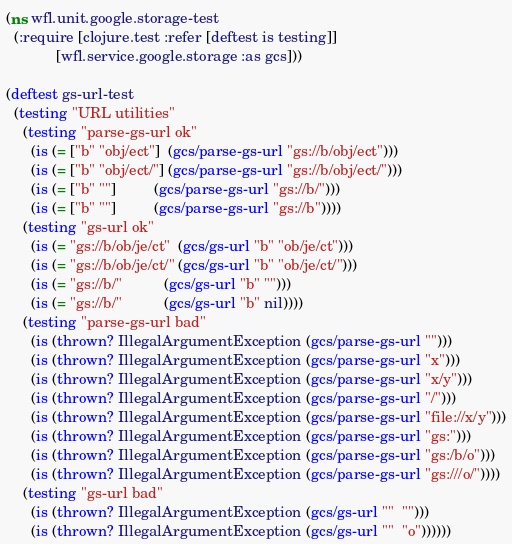<code> <loc_0><loc_0><loc_500><loc_500><_Clojure_>(ns wfl.unit.google.storage-test
  (:require [clojure.test :refer [deftest is testing]]
            [wfl.service.google.storage :as gcs]))

(deftest gs-url-test
  (testing "URL utilities"
    (testing "parse-gs-url ok"
      (is (= ["b" "obj/ect"]  (gcs/parse-gs-url "gs://b/obj/ect")))
      (is (= ["b" "obj/ect/"] (gcs/parse-gs-url "gs://b/obj/ect/")))
      (is (= ["b" ""]         (gcs/parse-gs-url "gs://b/")))
      (is (= ["b" ""]         (gcs/parse-gs-url "gs://b"))))
    (testing "gs-url ok"
      (is (= "gs://b/ob/je/ct"  (gcs/gs-url "b" "ob/je/ct")))
      (is (= "gs://b/ob/je/ct/" (gcs/gs-url "b" "ob/je/ct/")))
      (is (= "gs://b/"          (gcs/gs-url "b" "")))
      (is (= "gs://b/"          (gcs/gs-url "b" nil))))
    (testing "parse-gs-url bad"
      (is (thrown? IllegalArgumentException (gcs/parse-gs-url "")))
      (is (thrown? IllegalArgumentException (gcs/parse-gs-url "x")))
      (is (thrown? IllegalArgumentException (gcs/parse-gs-url "x/y")))
      (is (thrown? IllegalArgumentException (gcs/parse-gs-url "/")))
      (is (thrown? IllegalArgumentException (gcs/parse-gs-url "file://x/y")))
      (is (thrown? IllegalArgumentException (gcs/parse-gs-url "gs:")))
      (is (thrown? IllegalArgumentException (gcs/parse-gs-url "gs:/b/o")))
      (is (thrown? IllegalArgumentException (gcs/parse-gs-url "gs:///o/"))))
    (testing "gs-url bad"
      (is (thrown? IllegalArgumentException (gcs/gs-url ""  "")))
      (is (thrown? IllegalArgumentException (gcs/gs-url ""  "o"))))))
</code> 